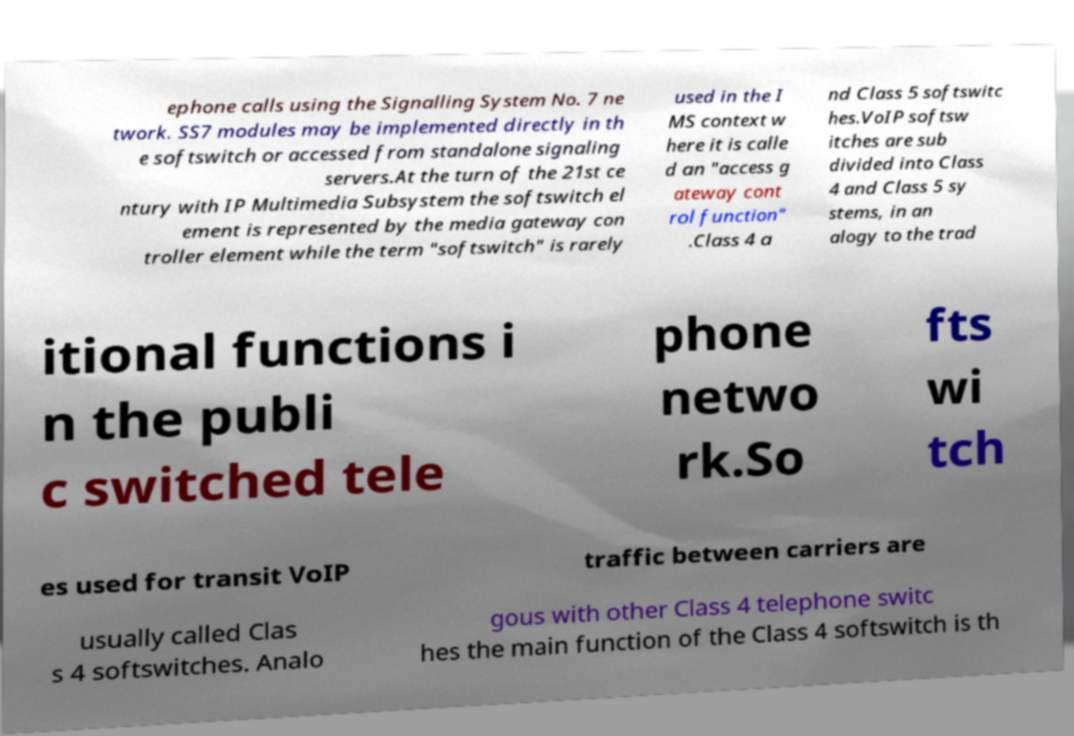I need the written content from this picture converted into text. Can you do that? ephone calls using the Signalling System No. 7 ne twork. SS7 modules may be implemented directly in th e softswitch or accessed from standalone signaling servers.At the turn of the 21st ce ntury with IP Multimedia Subsystem the softswitch el ement is represented by the media gateway con troller element while the term "softswitch" is rarely used in the I MS context w here it is calle d an "access g ateway cont rol function" .Class 4 a nd Class 5 softswitc hes.VoIP softsw itches are sub divided into Class 4 and Class 5 sy stems, in an alogy to the trad itional functions i n the publi c switched tele phone netwo rk.So fts wi tch es used for transit VoIP traffic between carriers are usually called Clas s 4 softswitches. Analo gous with other Class 4 telephone switc hes the main function of the Class 4 softswitch is th 